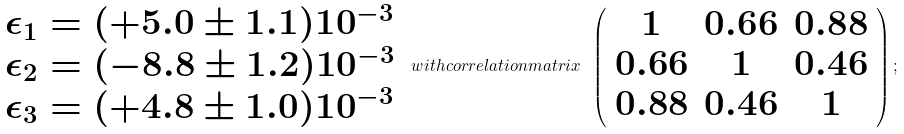Convert formula to latex. <formula><loc_0><loc_0><loc_500><loc_500>\begin{array} { l } \epsilon _ { 1 } = ( + 5 . 0 \pm 1 . 1 ) 1 0 ^ { - 3 } \\ \epsilon _ { 2 } = ( - 8 . 8 \pm 1 . 2 ) 1 0 ^ { - 3 } \\ \epsilon _ { 3 } = ( + 4 . 8 \pm 1 . 0 ) 1 0 ^ { - 3 } \end{array} \ w i t h c o r r e l a t i o n m a t r i x \ \left ( \begin{array} { c c c } 1 & 0 . 6 6 & 0 . 8 8 \\ 0 . 6 6 & 1 & 0 . 4 6 \\ 0 . 8 8 & 0 . 4 6 & 1 \end{array} \right ) ;</formula> 